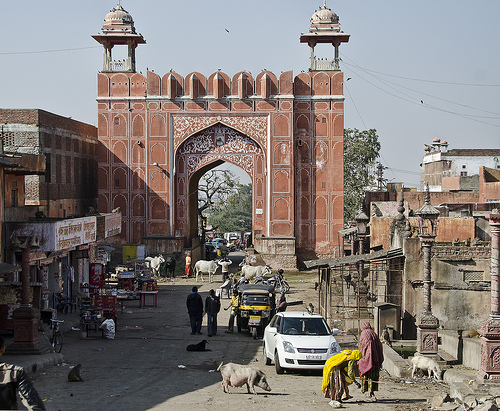<image>
Is there a tree behind the building? Yes. From this viewpoint, the tree is positioned behind the building, with the building partially or fully occluding the tree. Is there a pig behind the car? No. The pig is not behind the car. From this viewpoint, the pig appears to be positioned elsewhere in the scene. Is there a hog in front of the car? Yes. The hog is positioned in front of the car, appearing closer to the camera viewpoint. 